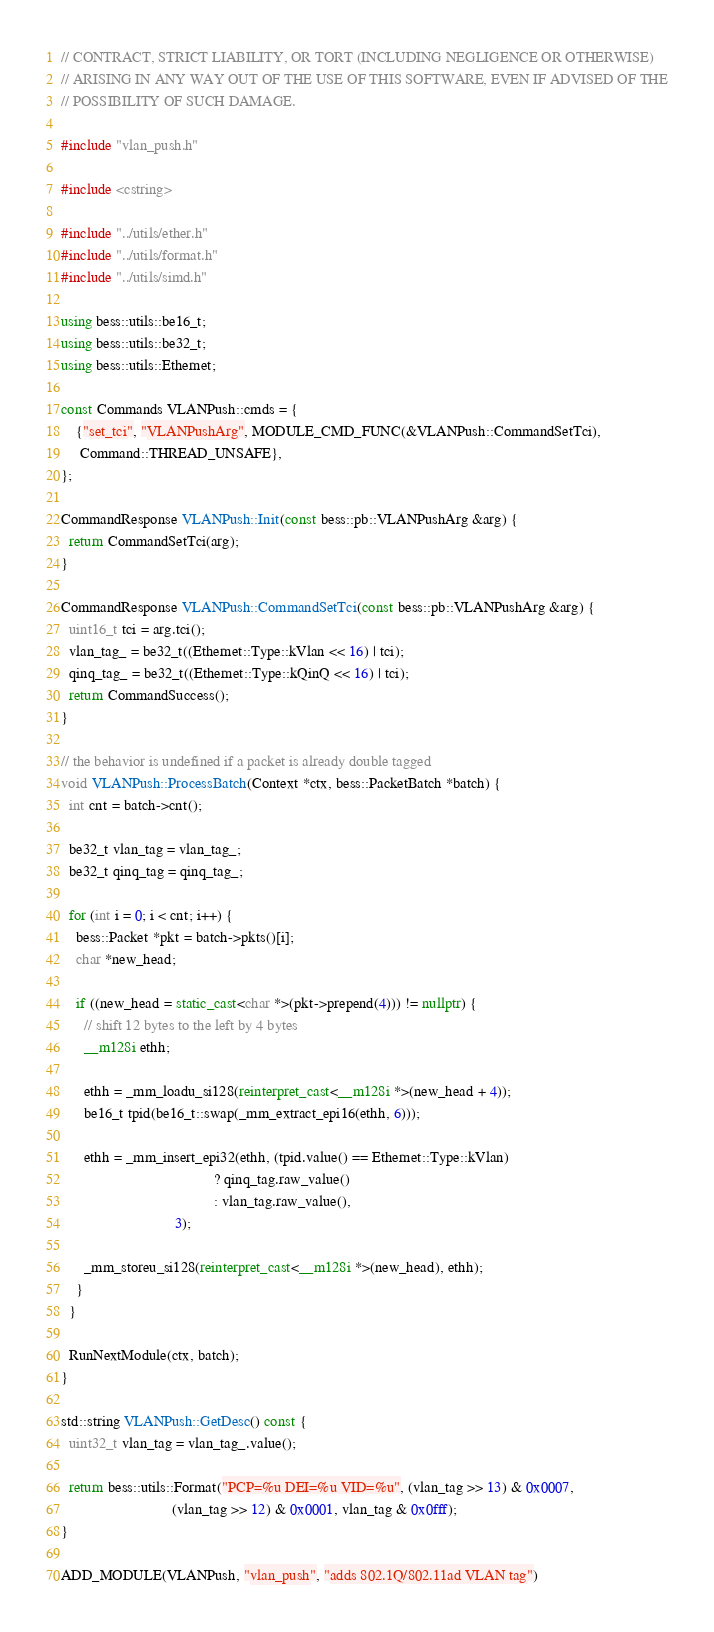<code> <loc_0><loc_0><loc_500><loc_500><_C++_>// CONTRACT, STRICT LIABILITY, OR TORT (INCLUDING NEGLIGENCE OR OTHERWISE)
// ARISING IN ANY WAY OUT OF THE USE OF THIS SOFTWARE, EVEN IF ADVISED OF THE
// POSSIBILITY OF SUCH DAMAGE.

#include "vlan_push.h"

#include <cstring>

#include "../utils/ether.h"
#include "../utils/format.h"
#include "../utils/simd.h"

using bess::utils::be16_t;
using bess::utils::be32_t;
using bess::utils::Ethernet;

const Commands VLANPush::cmds = {
    {"set_tci", "VLANPushArg", MODULE_CMD_FUNC(&VLANPush::CommandSetTci),
     Command::THREAD_UNSAFE},
};

CommandResponse VLANPush::Init(const bess::pb::VLANPushArg &arg) {
  return CommandSetTci(arg);
}

CommandResponse VLANPush::CommandSetTci(const bess::pb::VLANPushArg &arg) {
  uint16_t tci = arg.tci();
  vlan_tag_ = be32_t((Ethernet::Type::kVlan << 16) | tci);
  qinq_tag_ = be32_t((Ethernet::Type::kQinQ << 16) | tci);
  return CommandSuccess();
}

// the behavior is undefined if a packet is already double tagged
void VLANPush::ProcessBatch(Context *ctx, bess::PacketBatch *batch) {
  int cnt = batch->cnt();

  be32_t vlan_tag = vlan_tag_;
  be32_t qinq_tag = qinq_tag_;

  for (int i = 0; i < cnt; i++) {
    bess::Packet *pkt = batch->pkts()[i];
    char *new_head;

    if ((new_head = static_cast<char *>(pkt->prepend(4))) != nullptr) {
      // shift 12 bytes to the left by 4 bytes
      __m128i ethh;

      ethh = _mm_loadu_si128(reinterpret_cast<__m128i *>(new_head + 4));
      be16_t tpid(be16_t::swap(_mm_extract_epi16(ethh, 6)));

      ethh = _mm_insert_epi32(ethh, (tpid.value() == Ethernet::Type::kVlan)
                                        ? qinq_tag.raw_value()
                                        : vlan_tag.raw_value(),
                              3);

      _mm_storeu_si128(reinterpret_cast<__m128i *>(new_head), ethh);
    }
  }

  RunNextModule(ctx, batch);
}

std::string VLANPush::GetDesc() const {
  uint32_t vlan_tag = vlan_tag_.value();

  return bess::utils::Format("PCP=%u DEI=%u VID=%u", (vlan_tag >> 13) & 0x0007,
                             (vlan_tag >> 12) & 0x0001, vlan_tag & 0x0fff);
}

ADD_MODULE(VLANPush, "vlan_push", "adds 802.1Q/802.11ad VLAN tag")
</code> 